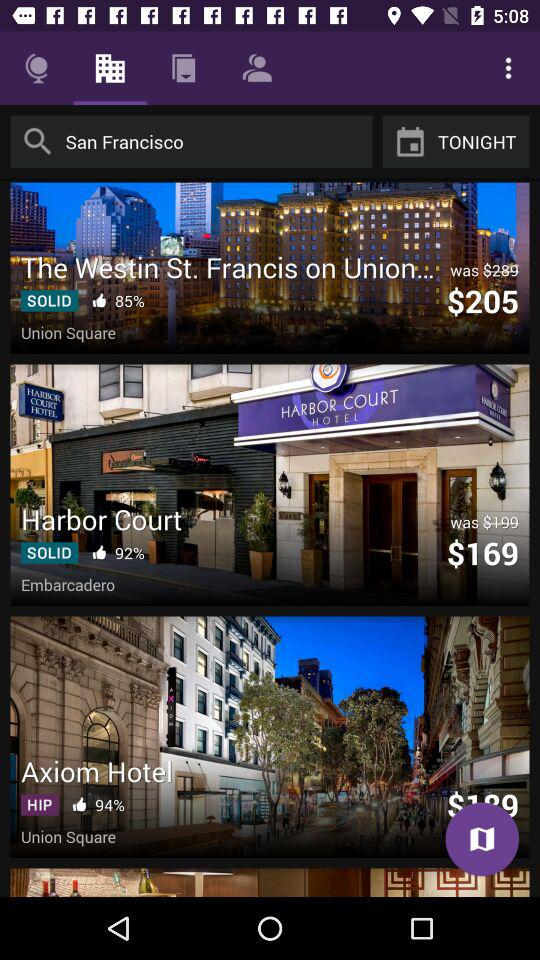What amenities are available at these hotels? The amenities at these hotels likely include complimentary Wi-Fi, on-site dining options, fitness centers, and business services. Given their high recommendation rates, each hotel is expected to offer a unique blend of comfort, convenience, and excellent customer service. For exact details, one would need to check each hotel's website or contact them directly. 